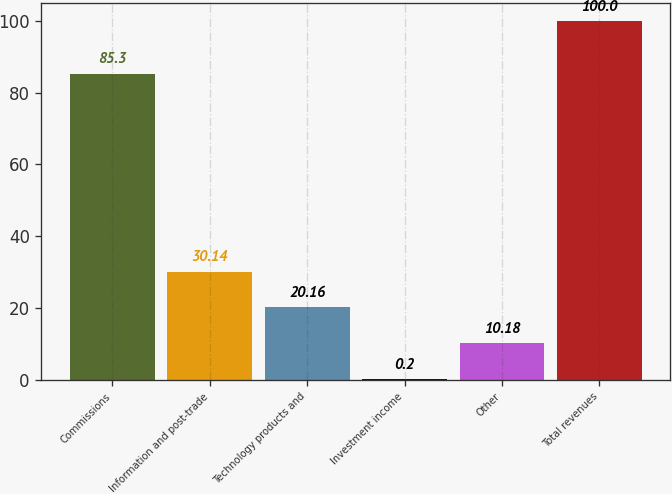Convert chart to OTSL. <chart><loc_0><loc_0><loc_500><loc_500><bar_chart><fcel>Commissions<fcel>Information and post-trade<fcel>Technology products and<fcel>Investment income<fcel>Other<fcel>Total revenues<nl><fcel>85.3<fcel>30.14<fcel>20.16<fcel>0.2<fcel>10.18<fcel>100<nl></chart> 